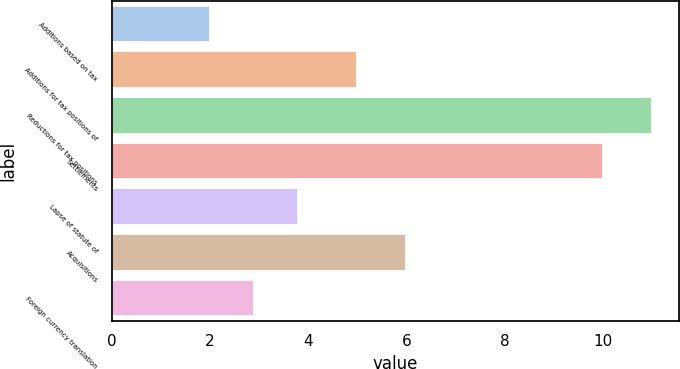<chart> <loc_0><loc_0><loc_500><loc_500><bar_chart><fcel>Additions based on tax<fcel>Additions for tax positions of<fcel>Reductions for tax positions<fcel>Settlements<fcel>Lapse of statute of<fcel>Acquisitions<fcel>Foreign currency translation<nl><fcel>2<fcel>5<fcel>11<fcel>10<fcel>3.8<fcel>6<fcel>2.9<nl></chart> 